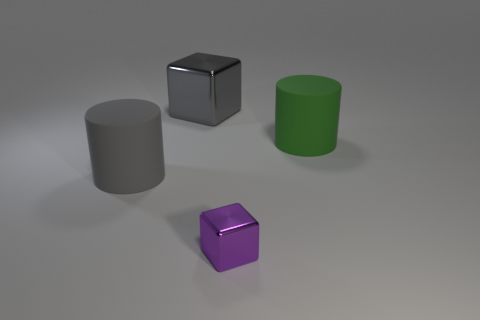The object that is the same material as the gray block is what shape?
Your response must be concise. Cube. What is the color of the other object that is the same material as the small thing?
Your answer should be very brief. Gray. There is a gray shiny object that is the same size as the green rubber thing; what is its shape?
Provide a short and direct response. Cube. Are there any other things that have the same shape as the gray metal object?
Make the answer very short. Yes. Do the cube that is in front of the big gray cylinder and the big gray block have the same material?
Give a very brief answer. Yes. There is a green cylinder that is the same size as the gray cube; what material is it?
Give a very brief answer. Rubber. How many other things are the same material as the green thing?
Your response must be concise. 1. Do the green object and the object that is behind the green cylinder have the same size?
Your answer should be compact. Yes. Is the number of large gray matte objects that are in front of the purple cube less than the number of big blocks on the left side of the gray cylinder?
Your answer should be very brief. No. What is the size of the metal cube that is behind the tiny metallic cube?
Offer a terse response. Large. 